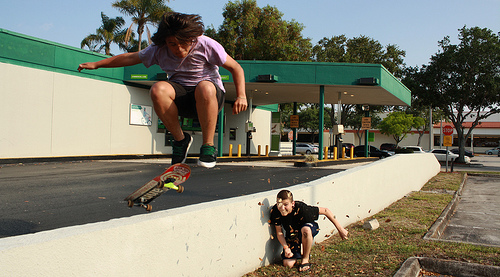Please provide a short description for this region: [0.19, 0.54, 0.38, 0.66]. This region captures a brown and red skateboard in motion. The skateboard is partly airborne and shows dynamic action, indicated by the blurred wheels and slight tilt. 